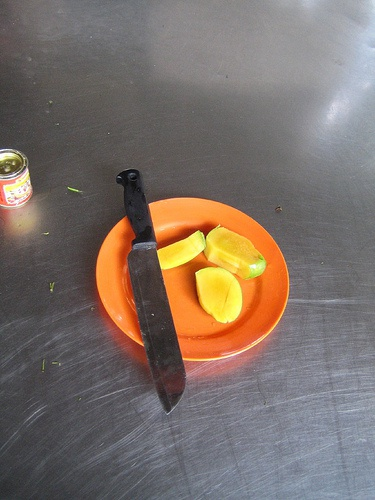Describe the objects in this image and their specific colors. I can see a knife in gray and black tones in this image. 